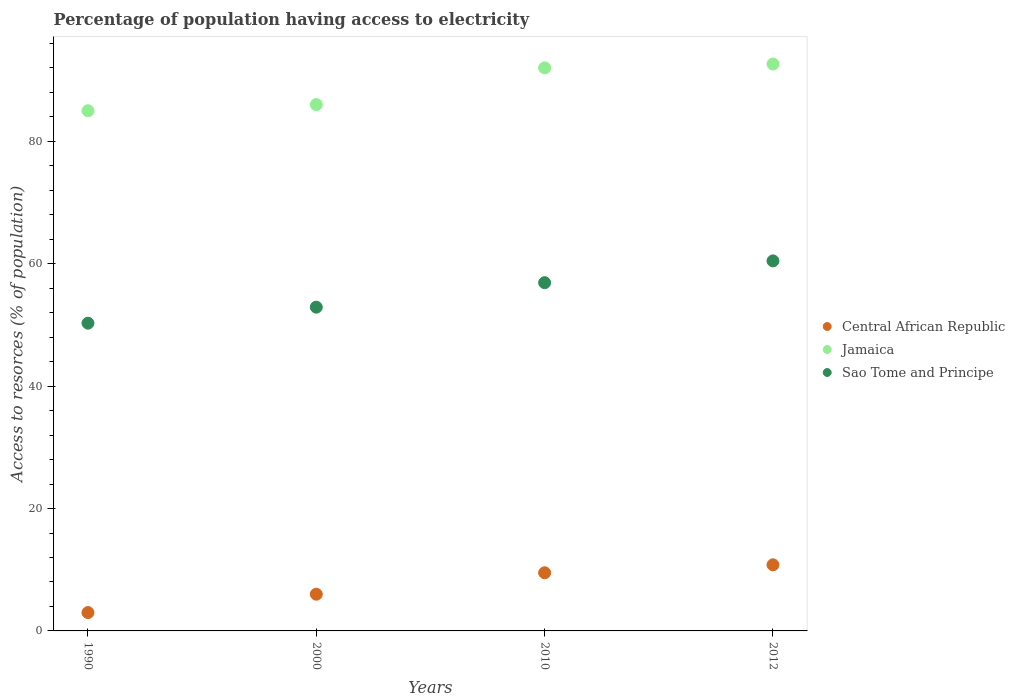What is the percentage of population having access to electricity in Central African Republic in 2010?
Make the answer very short. 9.5. Across all years, what is the maximum percentage of population having access to electricity in Jamaica?
Your answer should be very brief. 92.63. Across all years, what is the minimum percentage of population having access to electricity in Sao Tome and Principe?
Provide a short and direct response. 50.29. What is the total percentage of population having access to electricity in Sao Tome and Principe in the graph?
Provide a succinct answer. 220.55. What is the difference between the percentage of population having access to electricity in Sao Tome and Principe in 2000 and the percentage of population having access to electricity in Central African Republic in 2010?
Keep it short and to the point. 43.4. What is the average percentage of population having access to electricity in Sao Tome and Principe per year?
Make the answer very short. 55.14. In the year 2010, what is the difference between the percentage of population having access to electricity in Jamaica and percentage of population having access to electricity in Sao Tome and Principe?
Offer a very short reply. 35.1. What is the ratio of the percentage of population having access to electricity in Jamaica in 1990 to that in 2000?
Offer a very short reply. 0.99. Is the percentage of population having access to electricity in Jamaica in 1990 less than that in 2000?
Your answer should be very brief. Yes. Is the difference between the percentage of population having access to electricity in Jamaica in 2010 and 2012 greater than the difference between the percentage of population having access to electricity in Sao Tome and Principe in 2010 and 2012?
Make the answer very short. Yes. What is the difference between the highest and the second highest percentage of population having access to electricity in Sao Tome and Principe?
Ensure brevity in your answer.  3.56. What is the difference between the highest and the lowest percentage of population having access to electricity in Jamaica?
Keep it short and to the point. 7.63. Is it the case that in every year, the sum of the percentage of population having access to electricity in Sao Tome and Principe and percentage of population having access to electricity in Jamaica  is greater than the percentage of population having access to electricity in Central African Republic?
Provide a short and direct response. Yes. Is the percentage of population having access to electricity in Sao Tome and Principe strictly greater than the percentage of population having access to electricity in Jamaica over the years?
Offer a terse response. No. How many dotlines are there?
Offer a terse response. 3. Are the values on the major ticks of Y-axis written in scientific E-notation?
Your response must be concise. No. Where does the legend appear in the graph?
Give a very brief answer. Center right. How many legend labels are there?
Keep it short and to the point. 3. How are the legend labels stacked?
Provide a succinct answer. Vertical. What is the title of the graph?
Ensure brevity in your answer.  Percentage of population having access to electricity. Does "Somalia" appear as one of the legend labels in the graph?
Give a very brief answer. No. What is the label or title of the X-axis?
Your response must be concise. Years. What is the label or title of the Y-axis?
Offer a very short reply. Access to resorces (% of population). What is the Access to resorces (% of population) of Central African Republic in 1990?
Provide a succinct answer. 3. What is the Access to resorces (% of population) of Sao Tome and Principe in 1990?
Provide a succinct answer. 50.29. What is the Access to resorces (% of population) of Sao Tome and Principe in 2000?
Ensure brevity in your answer.  52.9. What is the Access to resorces (% of population) of Jamaica in 2010?
Give a very brief answer. 92. What is the Access to resorces (% of population) of Sao Tome and Principe in 2010?
Offer a very short reply. 56.9. What is the Access to resorces (% of population) of Jamaica in 2012?
Offer a very short reply. 92.63. What is the Access to resorces (% of population) in Sao Tome and Principe in 2012?
Your response must be concise. 60.46. Across all years, what is the maximum Access to resorces (% of population) in Jamaica?
Offer a very short reply. 92.63. Across all years, what is the maximum Access to resorces (% of population) in Sao Tome and Principe?
Your answer should be very brief. 60.46. Across all years, what is the minimum Access to resorces (% of population) in Central African Republic?
Keep it short and to the point. 3. Across all years, what is the minimum Access to resorces (% of population) in Sao Tome and Principe?
Your answer should be very brief. 50.29. What is the total Access to resorces (% of population) of Central African Republic in the graph?
Your answer should be very brief. 29.3. What is the total Access to resorces (% of population) of Jamaica in the graph?
Give a very brief answer. 355.63. What is the total Access to resorces (% of population) in Sao Tome and Principe in the graph?
Offer a terse response. 220.55. What is the difference between the Access to resorces (% of population) of Jamaica in 1990 and that in 2000?
Make the answer very short. -1. What is the difference between the Access to resorces (% of population) in Sao Tome and Principe in 1990 and that in 2000?
Make the answer very short. -2.61. What is the difference between the Access to resorces (% of population) of Jamaica in 1990 and that in 2010?
Your answer should be very brief. -7. What is the difference between the Access to resorces (% of population) in Sao Tome and Principe in 1990 and that in 2010?
Your answer should be very brief. -6.61. What is the difference between the Access to resorces (% of population) in Central African Republic in 1990 and that in 2012?
Provide a succinct answer. -7.8. What is the difference between the Access to resorces (% of population) in Jamaica in 1990 and that in 2012?
Ensure brevity in your answer.  -7.63. What is the difference between the Access to resorces (% of population) in Sao Tome and Principe in 1990 and that in 2012?
Offer a terse response. -10.17. What is the difference between the Access to resorces (% of population) in Central African Republic in 2000 and that in 2010?
Keep it short and to the point. -3.5. What is the difference between the Access to resorces (% of population) in Jamaica in 2000 and that in 2010?
Give a very brief answer. -6. What is the difference between the Access to resorces (% of population) of Jamaica in 2000 and that in 2012?
Make the answer very short. -6.63. What is the difference between the Access to resorces (% of population) of Sao Tome and Principe in 2000 and that in 2012?
Your response must be concise. -7.56. What is the difference between the Access to resorces (% of population) in Jamaica in 2010 and that in 2012?
Keep it short and to the point. -0.63. What is the difference between the Access to resorces (% of population) in Sao Tome and Principe in 2010 and that in 2012?
Ensure brevity in your answer.  -3.56. What is the difference between the Access to resorces (% of population) of Central African Republic in 1990 and the Access to resorces (% of population) of Jamaica in 2000?
Ensure brevity in your answer.  -83. What is the difference between the Access to resorces (% of population) in Central African Republic in 1990 and the Access to resorces (% of population) in Sao Tome and Principe in 2000?
Make the answer very short. -49.9. What is the difference between the Access to resorces (% of population) in Jamaica in 1990 and the Access to resorces (% of population) in Sao Tome and Principe in 2000?
Ensure brevity in your answer.  32.1. What is the difference between the Access to resorces (% of population) of Central African Republic in 1990 and the Access to resorces (% of population) of Jamaica in 2010?
Keep it short and to the point. -89. What is the difference between the Access to resorces (% of population) of Central African Republic in 1990 and the Access to resorces (% of population) of Sao Tome and Principe in 2010?
Make the answer very short. -53.9. What is the difference between the Access to resorces (% of population) of Jamaica in 1990 and the Access to resorces (% of population) of Sao Tome and Principe in 2010?
Make the answer very short. 28.1. What is the difference between the Access to resorces (% of population) in Central African Republic in 1990 and the Access to resorces (% of population) in Jamaica in 2012?
Make the answer very short. -89.63. What is the difference between the Access to resorces (% of population) of Central African Republic in 1990 and the Access to resorces (% of population) of Sao Tome and Principe in 2012?
Your answer should be very brief. -57.46. What is the difference between the Access to resorces (% of population) of Jamaica in 1990 and the Access to resorces (% of population) of Sao Tome and Principe in 2012?
Make the answer very short. 24.54. What is the difference between the Access to resorces (% of population) of Central African Republic in 2000 and the Access to resorces (% of population) of Jamaica in 2010?
Offer a very short reply. -86. What is the difference between the Access to resorces (% of population) of Central African Republic in 2000 and the Access to resorces (% of population) of Sao Tome and Principe in 2010?
Provide a short and direct response. -50.9. What is the difference between the Access to resorces (% of population) of Jamaica in 2000 and the Access to resorces (% of population) of Sao Tome and Principe in 2010?
Give a very brief answer. 29.1. What is the difference between the Access to resorces (% of population) in Central African Republic in 2000 and the Access to resorces (% of population) in Jamaica in 2012?
Provide a short and direct response. -86.63. What is the difference between the Access to resorces (% of population) of Central African Republic in 2000 and the Access to resorces (% of population) of Sao Tome and Principe in 2012?
Ensure brevity in your answer.  -54.46. What is the difference between the Access to resorces (% of population) in Jamaica in 2000 and the Access to resorces (% of population) in Sao Tome and Principe in 2012?
Your response must be concise. 25.54. What is the difference between the Access to resorces (% of population) of Central African Republic in 2010 and the Access to resorces (% of population) of Jamaica in 2012?
Offer a very short reply. -83.13. What is the difference between the Access to resorces (% of population) of Central African Republic in 2010 and the Access to resorces (% of population) of Sao Tome and Principe in 2012?
Provide a succinct answer. -50.96. What is the difference between the Access to resorces (% of population) of Jamaica in 2010 and the Access to resorces (% of population) of Sao Tome and Principe in 2012?
Provide a short and direct response. 31.54. What is the average Access to resorces (% of population) in Central African Republic per year?
Your response must be concise. 7.33. What is the average Access to resorces (% of population) in Jamaica per year?
Provide a succinct answer. 88.91. What is the average Access to resorces (% of population) in Sao Tome and Principe per year?
Keep it short and to the point. 55.14. In the year 1990, what is the difference between the Access to resorces (% of population) in Central African Republic and Access to resorces (% of population) in Jamaica?
Offer a very short reply. -82. In the year 1990, what is the difference between the Access to resorces (% of population) in Central African Republic and Access to resorces (% of population) in Sao Tome and Principe?
Offer a very short reply. -47.29. In the year 1990, what is the difference between the Access to resorces (% of population) in Jamaica and Access to resorces (% of population) in Sao Tome and Principe?
Ensure brevity in your answer.  34.71. In the year 2000, what is the difference between the Access to resorces (% of population) of Central African Republic and Access to resorces (% of population) of Jamaica?
Provide a succinct answer. -80. In the year 2000, what is the difference between the Access to resorces (% of population) of Central African Republic and Access to resorces (% of population) of Sao Tome and Principe?
Offer a very short reply. -46.9. In the year 2000, what is the difference between the Access to resorces (% of population) of Jamaica and Access to resorces (% of population) of Sao Tome and Principe?
Your answer should be compact. 33.1. In the year 2010, what is the difference between the Access to resorces (% of population) of Central African Republic and Access to resorces (% of population) of Jamaica?
Make the answer very short. -82.5. In the year 2010, what is the difference between the Access to resorces (% of population) in Central African Republic and Access to resorces (% of population) in Sao Tome and Principe?
Offer a very short reply. -47.4. In the year 2010, what is the difference between the Access to resorces (% of population) in Jamaica and Access to resorces (% of population) in Sao Tome and Principe?
Offer a terse response. 35.1. In the year 2012, what is the difference between the Access to resorces (% of population) of Central African Republic and Access to resorces (% of population) of Jamaica?
Provide a succinct answer. -81.83. In the year 2012, what is the difference between the Access to resorces (% of population) of Central African Republic and Access to resorces (% of population) of Sao Tome and Principe?
Your response must be concise. -49.66. In the year 2012, what is the difference between the Access to resorces (% of population) in Jamaica and Access to resorces (% of population) in Sao Tome and Principe?
Ensure brevity in your answer.  32.17. What is the ratio of the Access to resorces (% of population) of Central African Republic in 1990 to that in 2000?
Your answer should be very brief. 0.5. What is the ratio of the Access to resorces (% of population) of Jamaica in 1990 to that in 2000?
Your response must be concise. 0.99. What is the ratio of the Access to resorces (% of population) in Sao Tome and Principe in 1990 to that in 2000?
Give a very brief answer. 0.95. What is the ratio of the Access to resorces (% of population) of Central African Republic in 1990 to that in 2010?
Provide a succinct answer. 0.32. What is the ratio of the Access to resorces (% of population) in Jamaica in 1990 to that in 2010?
Keep it short and to the point. 0.92. What is the ratio of the Access to resorces (% of population) of Sao Tome and Principe in 1990 to that in 2010?
Offer a very short reply. 0.88. What is the ratio of the Access to resorces (% of population) in Central African Republic in 1990 to that in 2012?
Offer a terse response. 0.28. What is the ratio of the Access to resorces (% of population) of Jamaica in 1990 to that in 2012?
Make the answer very short. 0.92. What is the ratio of the Access to resorces (% of population) in Sao Tome and Principe in 1990 to that in 2012?
Provide a short and direct response. 0.83. What is the ratio of the Access to resorces (% of population) of Central African Republic in 2000 to that in 2010?
Keep it short and to the point. 0.63. What is the ratio of the Access to resorces (% of population) in Jamaica in 2000 to that in 2010?
Offer a very short reply. 0.93. What is the ratio of the Access to resorces (% of population) in Sao Tome and Principe in 2000 to that in 2010?
Your answer should be compact. 0.93. What is the ratio of the Access to resorces (% of population) in Central African Republic in 2000 to that in 2012?
Ensure brevity in your answer.  0.56. What is the ratio of the Access to resorces (% of population) of Jamaica in 2000 to that in 2012?
Your answer should be compact. 0.93. What is the ratio of the Access to resorces (% of population) in Sao Tome and Principe in 2000 to that in 2012?
Offer a terse response. 0.87. What is the ratio of the Access to resorces (% of population) of Central African Republic in 2010 to that in 2012?
Provide a short and direct response. 0.88. What is the ratio of the Access to resorces (% of population) in Sao Tome and Principe in 2010 to that in 2012?
Provide a short and direct response. 0.94. What is the difference between the highest and the second highest Access to resorces (% of population) of Jamaica?
Provide a short and direct response. 0.63. What is the difference between the highest and the second highest Access to resorces (% of population) in Sao Tome and Principe?
Ensure brevity in your answer.  3.56. What is the difference between the highest and the lowest Access to resorces (% of population) of Jamaica?
Ensure brevity in your answer.  7.63. What is the difference between the highest and the lowest Access to resorces (% of population) in Sao Tome and Principe?
Give a very brief answer. 10.17. 